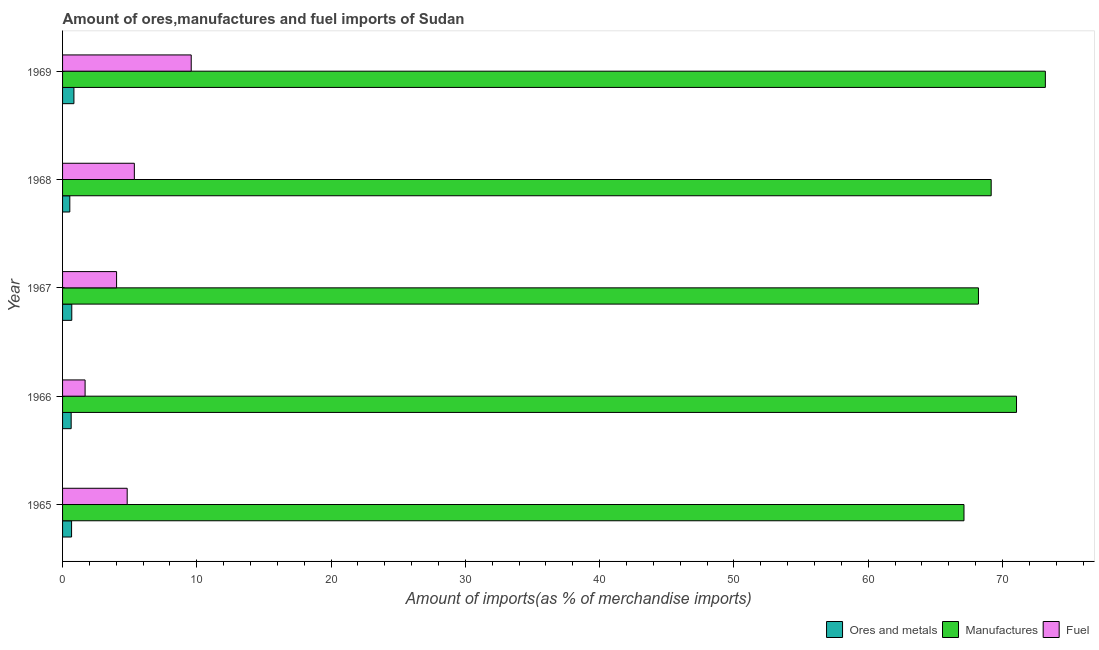How many bars are there on the 1st tick from the top?
Keep it short and to the point. 3. What is the label of the 3rd group of bars from the top?
Give a very brief answer. 1967. In how many cases, is the number of bars for a given year not equal to the number of legend labels?
Offer a very short reply. 0. What is the percentage of ores and metals imports in 1965?
Ensure brevity in your answer.  0.67. Across all years, what is the maximum percentage of fuel imports?
Your response must be concise. 9.58. Across all years, what is the minimum percentage of ores and metals imports?
Provide a succinct answer. 0.54. In which year was the percentage of ores and metals imports maximum?
Your response must be concise. 1969. In which year was the percentage of fuel imports minimum?
Make the answer very short. 1966. What is the total percentage of ores and metals imports in the graph?
Your response must be concise. 3.38. What is the difference between the percentage of ores and metals imports in 1967 and that in 1969?
Ensure brevity in your answer.  -0.16. What is the difference between the percentage of manufactures imports in 1965 and the percentage of ores and metals imports in 1967?
Provide a short and direct response. 66.45. What is the average percentage of ores and metals imports per year?
Give a very brief answer. 0.68. In the year 1969, what is the difference between the percentage of ores and metals imports and percentage of fuel imports?
Give a very brief answer. -8.74. In how many years, is the percentage of manufactures imports greater than 58 %?
Offer a terse response. 5. What is the ratio of the percentage of fuel imports in 1965 to that in 1966?
Ensure brevity in your answer.  2.87. What is the difference between the highest and the second highest percentage of manufactures imports?
Provide a succinct answer. 2.15. What is the difference between the highest and the lowest percentage of manufactures imports?
Offer a very short reply. 6.06. Is the sum of the percentage of manufactures imports in 1967 and 1968 greater than the maximum percentage of fuel imports across all years?
Provide a short and direct response. Yes. What does the 3rd bar from the top in 1966 represents?
Your answer should be compact. Ores and metals. What does the 2nd bar from the bottom in 1967 represents?
Offer a very short reply. Manufactures. Is it the case that in every year, the sum of the percentage of ores and metals imports and percentage of manufactures imports is greater than the percentage of fuel imports?
Make the answer very short. Yes. How many bars are there?
Provide a succinct answer. 15. What is the difference between two consecutive major ticks on the X-axis?
Provide a short and direct response. 10. Does the graph contain any zero values?
Keep it short and to the point. No. Does the graph contain grids?
Offer a very short reply. No. How many legend labels are there?
Ensure brevity in your answer.  3. What is the title of the graph?
Offer a terse response. Amount of ores,manufactures and fuel imports of Sudan. What is the label or title of the X-axis?
Your response must be concise. Amount of imports(as % of merchandise imports). What is the Amount of imports(as % of merchandise imports) of Ores and metals in 1965?
Ensure brevity in your answer.  0.67. What is the Amount of imports(as % of merchandise imports) in Manufactures in 1965?
Provide a short and direct response. 67.13. What is the Amount of imports(as % of merchandise imports) of Fuel in 1965?
Provide a succinct answer. 4.81. What is the Amount of imports(as % of merchandise imports) in Ores and metals in 1966?
Your response must be concise. 0.64. What is the Amount of imports(as % of merchandise imports) in Manufactures in 1966?
Your response must be concise. 71.05. What is the Amount of imports(as % of merchandise imports) of Fuel in 1966?
Keep it short and to the point. 1.68. What is the Amount of imports(as % of merchandise imports) in Ores and metals in 1967?
Give a very brief answer. 0.69. What is the Amount of imports(as % of merchandise imports) of Manufactures in 1967?
Your answer should be compact. 68.21. What is the Amount of imports(as % of merchandise imports) in Fuel in 1967?
Keep it short and to the point. 4.02. What is the Amount of imports(as % of merchandise imports) in Ores and metals in 1968?
Provide a short and direct response. 0.54. What is the Amount of imports(as % of merchandise imports) of Manufactures in 1968?
Provide a short and direct response. 69.16. What is the Amount of imports(as % of merchandise imports) in Fuel in 1968?
Your answer should be very brief. 5.35. What is the Amount of imports(as % of merchandise imports) in Ores and metals in 1969?
Provide a succinct answer. 0.85. What is the Amount of imports(as % of merchandise imports) in Manufactures in 1969?
Ensure brevity in your answer.  73.19. What is the Amount of imports(as % of merchandise imports) in Fuel in 1969?
Give a very brief answer. 9.58. Across all years, what is the maximum Amount of imports(as % of merchandise imports) of Ores and metals?
Your response must be concise. 0.85. Across all years, what is the maximum Amount of imports(as % of merchandise imports) of Manufactures?
Give a very brief answer. 73.19. Across all years, what is the maximum Amount of imports(as % of merchandise imports) of Fuel?
Provide a short and direct response. 9.58. Across all years, what is the minimum Amount of imports(as % of merchandise imports) of Ores and metals?
Offer a very short reply. 0.54. Across all years, what is the minimum Amount of imports(as % of merchandise imports) of Manufactures?
Your response must be concise. 67.13. Across all years, what is the minimum Amount of imports(as % of merchandise imports) of Fuel?
Your response must be concise. 1.68. What is the total Amount of imports(as % of merchandise imports) in Ores and metals in the graph?
Make the answer very short. 3.38. What is the total Amount of imports(as % of merchandise imports) of Manufactures in the graph?
Your answer should be very brief. 348.74. What is the total Amount of imports(as % of merchandise imports) of Fuel in the graph?
Offer a terse response. 25.44. What is the difference between the Amount of imports(as % of merchandise imports) in Ores and metals in 1965 and that in 1966?
Give a very brief answer. 0.03. What is the difference between the Amount of imports(as % of merchandise imports) of Manufactures in 1965 and that in 1966?
Offer a terse response. -3.91. What is the difference between the Amount of imports(as % of merchandise imports) of Fuel in 1965 and that in 1966?
Offer a terse response. 3.14. What is the difference between the Amount of imports(as % of merchandise imports) in Ores and metals in 1965 and that in 1967?
Give a very brief answer. -0.02. What is the difference between the Amount of imports(as % of merchandise imports) of Manufactures in 1965 and that in 1967?
Offer a very short reply. -1.08. What is the difference between the Amount of imports(as % of merchandise imports) in Fuel in 1965 and that in 1967?
Provide a succinct answer. 0.79. What is the difference between the Amount of imports(as % of merchandise imports) in Ores and metals in 1965 and that in 1968?
Provide a short and direct response. 0.13. What is the difference between the Amount of imports(as % of merchandise imports) of Manufactures in 1965 and that in 1968?
Keep it short and to the point. -2.03. What is the difference between the Amount of imports(as % of merchandise imports) of Fuel in 1965 and that in 1968?
Make the answer very short. -0.53. What is the difference between the Amount of imports(as % of merchandise imports) in Ores and metals in 1965 and that in 1969?
Keep it short and to the point. -0.17. What is the difference between the Amount of imports(as % of merchandise imports) of Manufactures in 1965 and that in 1969?
Your response must be concise. -6.06. What is the difference between the Amount of imports(as % of merchandise imports) in Fuel in 1965 and that in 1969?
Give a very brief answer. -4.77. What is the difference between the Amount of imports(as % of merchandise imports) in Ores and metals in 1966 and that in 1967?
Provide a succinct answer. -0.05. What is the difference between the Amount of imports(as % of merchandise imports) of Manufactures in 1966 and that in 1967?
Your response must be concise. 2.84. What is the difference between the Amount of imports(as % of merchandise imports) of Fuel in 1966 and that in 1967?
Give a very brief answer. -2.35. What is the difference between the Amount of imports(as % of merchandise imports) in Ores and metals in 1966 and that in 1968?
Give a very brief answer. 0.1. What is the difference between the Amount of imports(as % of merchandise imports) in Manufactures in 1966 and that in 1968?
Your answer should be compact. 1.89. What is the difference between the Amount of imports(as % of merchandise imports) of Fuel in 1966 and that in 1968?
Your answer should be very brief. -3.67. What is the difference between the Amount of imports(as % of merchandise imports) in Ores and metals in 1966 and that in 1969?
Your response must be concise. -0.21. What is the difference between the Amount of imports(as % of merchandise imports) of Manufactures in 1966 and that in 1969?
Offer a very short reply. -2.15. What is the difference between the Amount of imports(as % of merchandise imports) of Fuel in 1966 and that in 1969?
Your response must be concise. -7.9. What is the difference between the Amount of imports(as % of merchandise imports) in Ores and metals in 1967 and that in 1968?
Provide a short and direct response. 0.15. What is the difference between the Amount of imports(as % of merchandise imports) in Manufactures in 1967 and that in 1968?
Provide a short and direct response. -0.95. What is the difference between the Amount of imports(as % of merchandise imports) of Fuel in 1967 and that in 1968?
Provide a short and direct response. -1.32. What is the difference between the Amount of imports(as % of merchandise imports) in Ores and metals in 1967 and that in 1969?
Offer a terse response. -0.16. What is the difference between the Amount of imports(as % of merchandise imports) of Manufactures in 1967 and that in 1969?
Keep it short and to the point. -4.98. What is the difference between the Amount of imports(as % of merchandise imports) in Fuel in 1967 and that in 1969?
Provide a short and direct response. -5.56. What is the difference between the Amount of imports(as % of merchandise imports) of Ores and metals in 1968 and that in 1969?
Give a very brief answer. -0.31. What is the difference between the Amount of imports(as % of merchandise imports) in Manufactures in 1968 and that in 1969?
Give a very brief answer. -4.03. What is the difference between the Amount of imports(as % of merchandise imports) in Fuel in 1968 and that in 1969?
Offer a terse response. -4.24. What is the difference between the Amount of imports(as % of merchandise imports) in Ores and metals in 1965 and the Amount of imports(as % of merchandise imports) in Manufactures in 1966?
Provide a short and direct response. -70.37. What is the difference between the Amount of imports(as % of merchandise imports) of Ores and metals in 1965 and the Amount of imports(as % of merchandise imports) of Fuel in 1966?
Provide a succinct answer. -1.01. What is the difference between the Amount of imports(as % of merchandise imports) in Manufactures in 1965 and the Amount of imports(as % of merchandise imports) in Fuel in 1966?
Provide a short and direct response. 65.46. What is the difference between the Amount of imports(as % of merchandise imports) of Ores and metals in 1965 and the Amount of imports(as % of merchandise imports) of Manufactures in 1967?
Provide a succinct answer. -67.54. What is the difference between the Amount of imports(as % of merchandise imports) of Ores and metals in 1965 and the Amount of imports(as % of merchandise imports) of Fuel in 1967?
Make the answer very short. -3.35. What is the difference between the Amount of imports(as % of merchandise imports) of Manufactures in 1965 and the Amount of imports(as % of merchandise imports) of Fuel in 1967?
Give a very brief answer. 63.11. What is the difference between the Amount of imports(as % of merchandise imports) in Ores and metals in 1965 and the Amount of imports(as % of merchandise imports) in Manufactures in 1968?
Ensure brevity in your answer.  -68.49. What is the difference between the Amount of imports(as % of merchandise imports) in Ores and metals in 1965 and the Amount of imports(as % of merchandise imports) in Fuel in 1968?
Your answer should be very brief. -4.67. What is the difference between the Amount of imports(as % of merchandise imports) in Manufactures in 1965 and the Amount of imports(as % of merchandise imports) in Fuel in 1968?
Your answer should be compact. 61.79. What is the difference between the Amount of imports(as % of merchandise imports) in Ores and metals in 1965 and the Amount of imports(as % of merchandise imports) in Manufactures in 1969?
Provide a succinct answer. -72.52. What is the difference between the Amount of imports(as % of merchandise imports) of Ores and metals in 1965 and the Amount of imports(as % of merchandise imports) of Fuel in 1969?
Ensure brevity in your answer.  -8.91. What is the difference between the Amount of imports(as % of merchandise imports) in Manufactures in 1965 and the Amount of imports(as % of merchandise imports) in Fuel in 1969?
Give a very brief answer. 57.55. What is the difference between the Amount of imports(as % of merchandise imports) in Ores and metals in 1966 and the Amount of imports(as % of merchandise imports) in Manufactures in 1967?
Keep it short and to the point. -67.57. What is the difference between the Amount of imports(as % of merchandise imports) of Ores and metals in 1966 and the Amount of imports(as % of merchandise imports) of Fuel in 1967?
Offer a terse response. -3.38. What is the difference between the Amount of imports(as % of merchandise imports) of Manufactures in 1966 and the Amount of imports(as % of merchandise imports) of Fuel in 1967?
Give a very brief answer. 67.02. What is the difference between the Amount of imports(as % of merchandise imports) in Ores and metals in 1966 and the Amount of imports(as % of merchandise imports) in Manufactures in 1968?
Keep it short and to the point. -68.52. What is the difference between the Amount of imports(as % of merchandise imports) in Ores and metals in 1966 and the Amount of imports(as % of merchandise imports) in Fuel in 1968?
Your answer should be very brief. -4.71. What is the difference between the Amount of imports(as % of merchandise imports) in Manufactures in 1966 and the Amount of imports(as % of merchandise imports) in Fuel in 1968?
Your answer should be compact. 65.7. What is the difference between the Amount of imports(as % of merchandise imports) in Ores and metals in 1966 and the Amount of imports(as % of merchandise imports) in Manufactures in 1969?
Make the answer very short. -72.55. What is the difference between the Amount of imports(as % of merchandise imports) of Ores and metals in 1966 and the Amount of imports(as % of merchandise imports) of Fuel in 1969?
Offer a terse response. -8.94. What is the difference between the Amount of imports(as % of merchandise imports) of Manufactures in 1966 and the Amount of imports(as % of merchandise imports) of Fuel in 1969?
Keep it short and to the point. 61.46. What is the difference between the Amount of imports(as % of merchandise imports) of Ores and metals in 1967 and the Amount of imports(as % of merchandise imports) of Manufactures in 1968?
Provide a succinct answer. -68.47. What is the difference between the Amount of imports(as % of merchandise imports) of Ores and metals in 1967 and the Amount of imports(as % of merchandise imports) of Fuel in 1968?
Ensure brevity in your answer.  -4.66. What is the difference between the Amount of imports(as % of merchandise imports) of Manufactures in 1967 and the Amount of imports(as % of merchandise imports) of Fuel in 1968?
Offer a very short reply. 62.87. What is the difference between the Amount of imports(as % of merchandise imports) in Ores and metals in 1967 and the Amount of imports(as % of merchandise imports) in Manufactures in 1969?
Offer a terse response. -72.51. What is the difference between the Amount of imports(as % of merchandise imports) of Ores and metals in 1967 and the Amount of imports(as % of merchandise imports) of Fuel in 1969?
Offer a very short reply. -8.9. What is the difference between the Amount of imports(as % of merchandise imports) in Manufactures in 1967 and the Amount of imports(as % of merchandise imports) in Fuel in 1969?
Ensure brevity in your answer.  58.63. What is the difference between the Amount of imports(as % of merchandise imports) in Ores and metals in 1968 and the Amount of imports(as % of merchandise imports) in Manufactures in 1969?
Provide a short and direct response. -72.65. What is the difference between the Amount of imports(as % of merchandise imports) in Ores and metals in 1968 and the Amount of imports(as % of merchandise imports) in Fuel in 1969?
Your answer should be very brief. -9.04. What is the difference between the Amount of imports(as % of merchandise imports) in Manufactures in 1968 and the Amount of imports(as % of merchandise imports) in Fuel in 1969?
Your response must be concise. 59.58. What is the average Amount of imports(as % of merchandise imports) in Ores and metals per year?
Offer a very short reply. 0.68. What is the average Amount of imports(as % of merchandise imports) in Manufactures per year?
Your response must be concise. 69.75. What is the average Amount of imports(as % of merchandise imports) of Fuel per year?
Ensure brevity in your answer.  5.09. In the year 1965, what is the difference between the Amount of imports(as % of merchandise imports) in Ores and metals and Amount of imports(as % of merchandise imports) in Manufactures?
Provide a succinct answer. -66.46. In the year 1965, what is the difference between the Amount of imports(as % of merchandise imports) of Ores and metals and Amount of imports(as % of merchandise imports) of Fuel?
Your answer should be very brief. -4.14. In the year 1965, what is the difference between the Amount of imports(as % of merchandise imports) of Manufactures and Amount of imports(as % of merchandise imports) of Fuel?
Your answer should be compact. 62.32. In the year 1966, what is the difference between the Amount of imports(as % of merchandise imports) of Ores and metals and Amount of imports(as % of merchandise imports) of Manufactures?
Offer a very short reply. -70.41. In the year 1966, what is the difference between the Amount of imports(as % of merchandise imports) of Ores and metals and Amount of imports(as % of merchandise imports) of Fuel?
Offer a very short reply. -1.04. In the year 1966, what is the difference between the Amount of imports(as % of merchandise imports) in Manufactures and Amount of imports(as % of merchandise imports) in Fuel?
Keep it short and to the point. 69.37. In the year 1967, what is the difference between the Amount of imports(as % of merchandise imports) of Ores and metals and Amount of imports(as % of merchandise imports) of Manufactures?
Offer a very short reply. -67.52. In the year 1967, what is the difference between the Amount of imports(as % of merchandise imports) in Ores and metals and Amount of imports(as % of merchandise imports) in Fuel?
Your response must be concise. -3.34. In the year 1967, what is the difference between the Amount of imports(as % of merchandise imports) of Manufactures and Amount of imports(as % of merchandise imports) of Fuel?
Keep it short and to the point. 64.19. In the year 1968, what is the difference between the Amount of imports(as % of merchandise imports) of Ores and metals and Amount of imports(as % of merchandise imports) of Manufactures?
Your answer should be very brief. -68.62. In the year 1968, what is the difference between the Amount of imports(as % of merchandise imports) of Ores and metals and Amount of imports(as % of merchandise imports) of Fuel?
Your answer should be compact. -4.81. In the year 1968, what is the difference between the Amount of imports(as % of merchandise imports) of Manufactures and Amount of imports(as % of merchandise imports) of Fuel?
Your response must be concise. 63.81. In the year 1969, what is the difference between the Amount of imports(as % of merchandise imports) in Ores and metals and Amount of imports(as % of merchandise imports) in Manufactures?
Ensure brevity in your answer.  -72.35. In the year 1969, what is the difference between the Amount of imports(as % of merchandise imports) in Ores and metals and Amount of imports(as % of merchandise imports) in Fuel?
Offer a terse response. -8.74. In the year 1969, what is the difference between the Amount of imports(as % of merchandise imports) in Manufactures and Amount of imports(as % of merchandise imports) in Fuel?
Provide a short and direct response. 63.61. What is the ratio of the Amount of imports(as % of merchandise imports) in Ores and metals in 1965 to that in 1966?
Give a very brief answer. 1.05. What is the ratio of the Amount of imports(as % of merchandise imports) of Manufactures in 1965 to that in 1966?
Offer a terse response. 0.94. What is the ratio of the Amount of imports(as % of merchandise imports) of Fuel in 1965 to that in 1966?
Your answer should be very brief. 2.87. What is the ratio of the Amount of imports(as % of merchandise imports) in Ores and metals in 1965 to that in 1967?
Keep it short and to the point. 0.98. What is the ratio of the Amount of imports(as % of merchandise imports) of Manufactures in 1965 to that in 1967?
Your answer should be very brief. 0.98. What is the ratio of the Amount of imports(as % of merchandise imports) in Fuel in 1965 to that in 1967?
Keep it short and to the point. 1.2. What is the ratio of the Amount of imports(as % of merchandise imports) of Ores and metals in 1965 to that in 1968?
Keep it short and to the point. 1.24. What is the ratio of the Amount of imports(as % of merchandise imports) in Manufactures in 1965 to that in 1968?
Give a very brief answer. 0.97. What is the ratio of the Amount of imports(as % of merchandise imports) of Fuel in 1965 to that in 1968?
Your answer should be very brief. 0.9. What is the ratio of the Amount of imports(as % of merchandise imports) of Ores and metals in 1965 to that in 1969?
Offer a terse response. 0.79. What is the ratio of the Amount of imports(as % of merchandise imports) of Manufactures in 1965 to that in 1969?
Your response must be concise. 0.92. What is the ratio of the Amount of imports(as % of merchandise imports) in Fuel in 1965 to that in 1969?
Provide a short and direct response. 0.5. What is the ratio of the Amount of imports(as % of merchandise imports) of Ores and metals in 1966 to that in 1967?
Ensure brevity in your answer.  0.93. What is the ratio of the Amount of imports(as % of merchandise imports) in Manufactures in 1966 to that in 1967?
Keep it short and to the point. 1.04. What is the ratio of the Amount of imports(as % of merchandise imports) of Fuel in 1966 to that in 1967?
Your answer should be compact. 0.42. What is the ratio of the Amount of imports(as % of merchandise imports) of Ores and metals in 1966 to that in 1968?
Provide a short and direct response. 1.19. What is the ratio of the Amount of imports(as % of merchandise imports) in Manufactures in 1966 to that in 1968?
Make the answer very short. 1.03. What is the ratio of the Amount of imports(as % of merchandise imports) of Fuel in 1966 to that in 1968?
Provide a short and direct response. 0.31. What is the ratio of the Amount of imports(as % of merchandise imports) in Ores and metals in 1966 to that in 1969?
Keep it short and to the point. 0.76. What is the ratio of the Amount of imports(as % of merchandise imports) of Manufactures in 1966 to that in 1969?
Provide a succinct answer. 0.97. What is the ratio of the Amount of imports(as % of merchandise imports) of Fuel in 1966 to that in 1969?
Keep it short and to the point. 0.18. What is the ratio of the Amount of imports(as % of merchandise imports) of Ores and metals in 1967 to that in 1968?
Provide a succinct answer. 1.27. What is the ratio of the Amount of imports(as % of merchandise imports) of Manufactures in 1967 to that in 1968?
Ensure brevity in your answer.  0.99. What is the ratio of the Amount of imports(as % of merchandise imports) of Fuel in 1967 to that in 1968?
Your answer should be very brief. 0.75. What is the ratio of the Amount of imports(as % of merchandise imports) of Ores and metals in 1967 to that in 1969?
Your answer should be very brief. 0.81. What is the ratio of the Amount of imports(as % of merchandise imports) of Manufactures in 1967 to that in 1969?
Make the answer very short. 0.93. What is the ratio of the Amount of imports(as % of merchandise imports) of Fuel in 1967 to that in 1969?
Make the answer very short. 0.42. What is the ratio of the Amount of imports(as % of merchandise imports) of Ores and metals in 1968 to that in 1969?
Give a very brief answer. 0.64. What is the ratio of the Amount of imports(as % of merchandise imports) in Manufactures in 1968 to that in 1969?
Your answer should be very brief. 0.94. What is the ratio of the Amount of imports(as % of merchandise imports) of Fuel in 1968 to that in 1969?
Make the answer very short. 0.56. What is the difference between the highest and the second highest Amount of imports(as % of merchandise imports) of Ores and metals?
Keep it short and to the point. 0.16. What is the difference between the highest and the second highest Amount of imports(as % of merchandise imports) of Manufactures?
Your response must be concise. 2.15. What is the difference between the highest and the second highest Amount of imports(as % of merchandise imports) in Fuel?
Offer a very short reply. 4.24. What is the difference between the highest and the lowest Amount of imports(as % of merchandise imports) in Ores and metals?
Make the answer very short. 0.31. What is the difference between the highest and the lowest Amount of imports(as % of merchandise imports) in Manufactures?
Give a very brief answer. 6.06. What is the difference between the highest and the lowest Amount of imports(as % of merchandise imports) of Fuel?
Ensure brevity in your answer.  7.9. 